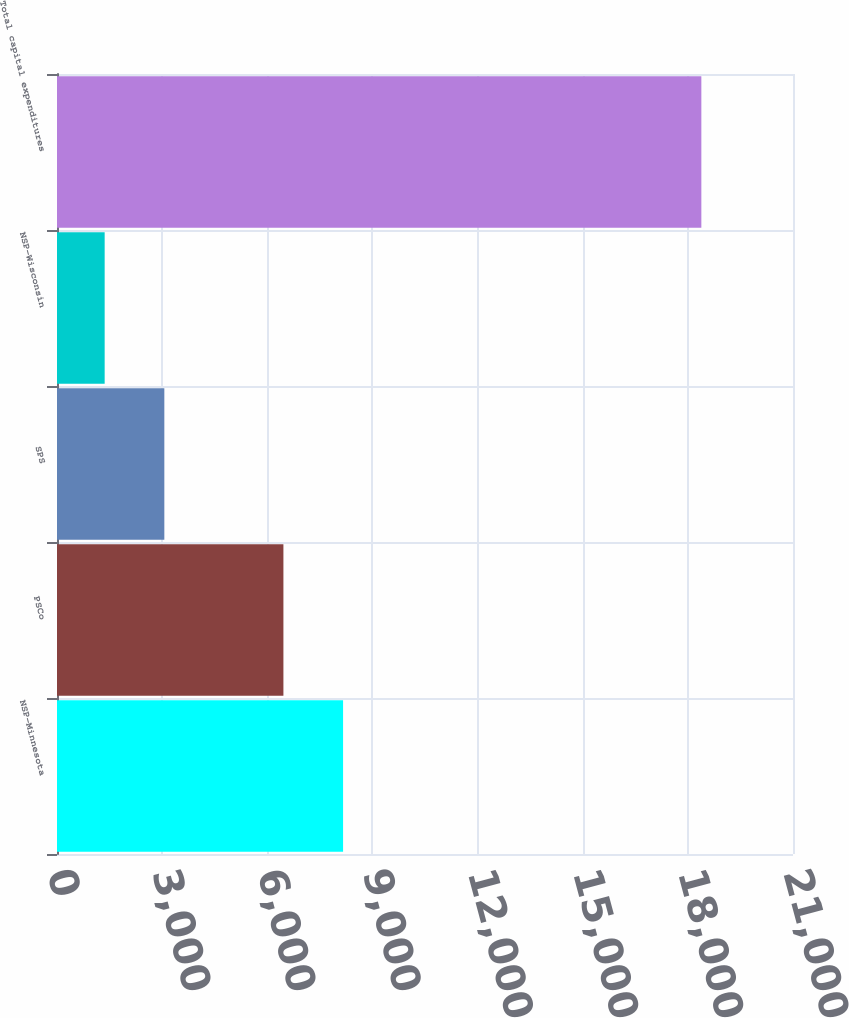<chart> <loc_0><loc_0><loc_500><loc_500><bar_chart><fcel>NSP-Minnesota<fcel>PSCo<fcel>SPS<fcel>NSP-Wisconsin<fcel>Total capital expenditures<nl><fcel>8162.5<fcel>6460<fcel>3062.5<fcel>1360<fcel>18385<nl></chart> 